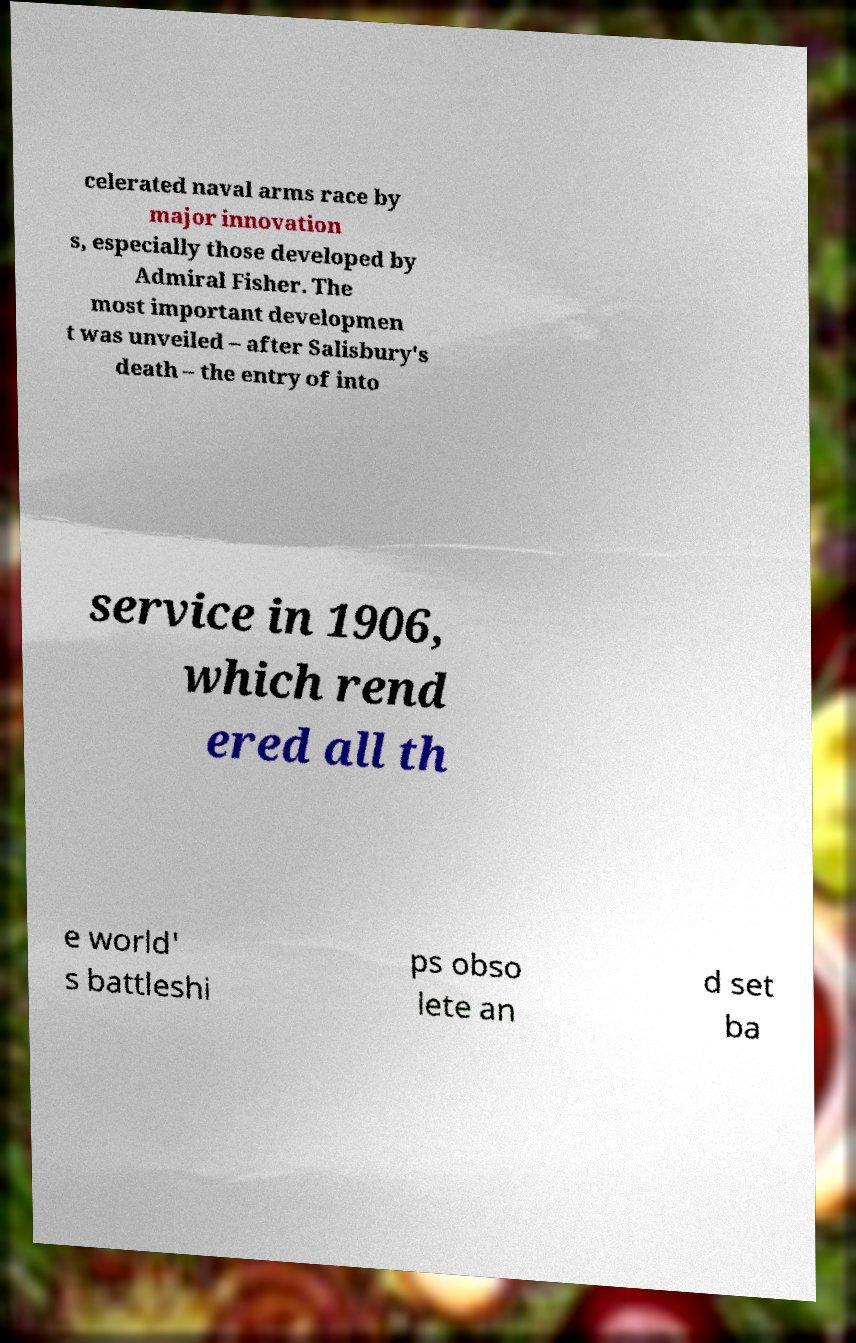Could you assist in decoding the text presented in this image and type it out clearly? celerated naval arms race by major innovation s, especially those developed by Admiral Fisher. The most important developmen t was unveiled – after Salisbury's death – the entry of into service in 1906, which rend ered all th e world' s battleshi ps obso lete an d set ba 